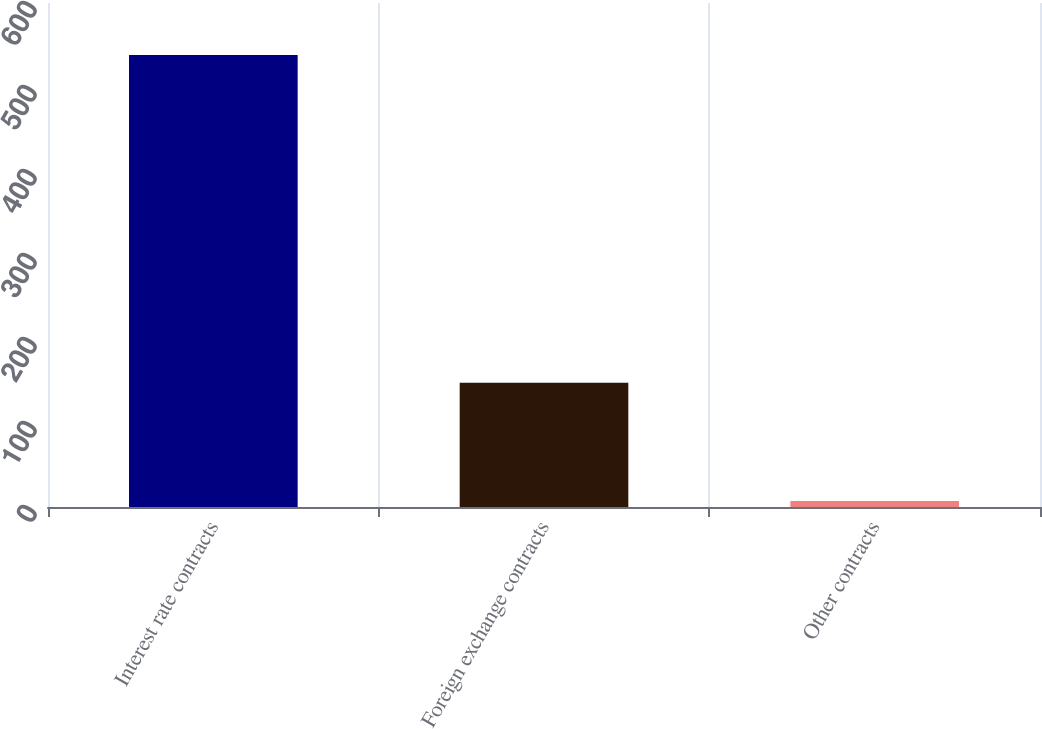Convert chart to OTSL. <chart><loc_0><loc_0><loc_500><loc_500><bar_chart><fcel>Interest rate contracts<fcel>Foreign exchange contracts<fcel>Other contracts<nl><fcel>538<fcel>148<fcel>7<nl></chart> 